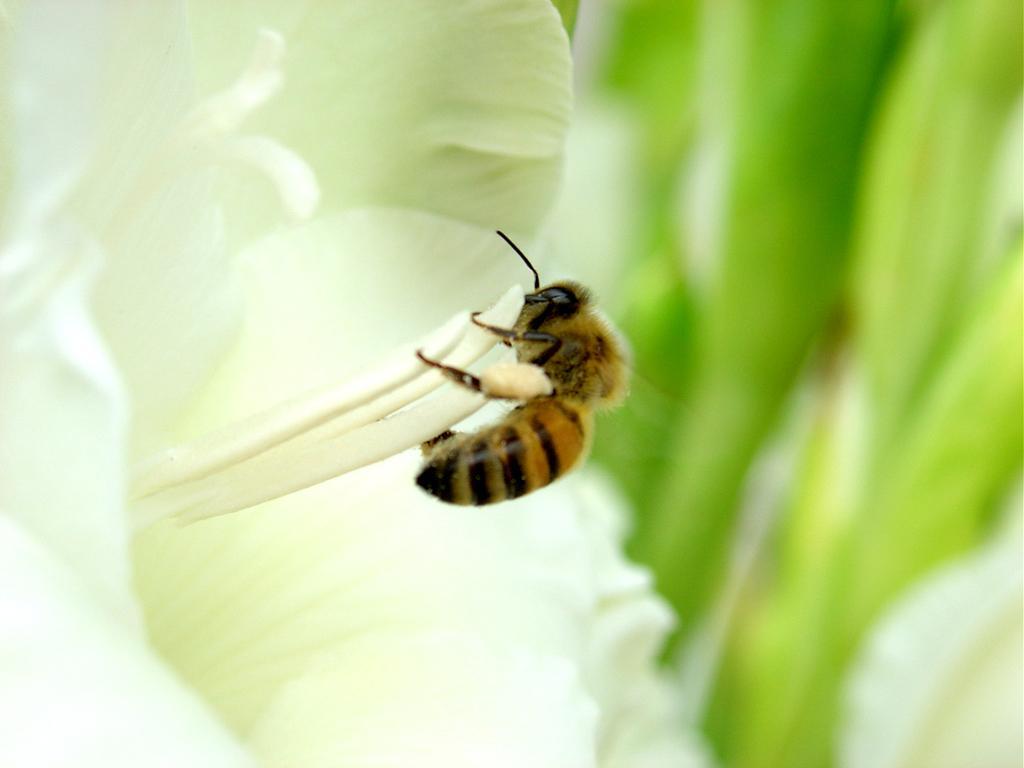Describe this image in one or two sentences. In the image we can see the bee on the white flower and the background is blurred. 